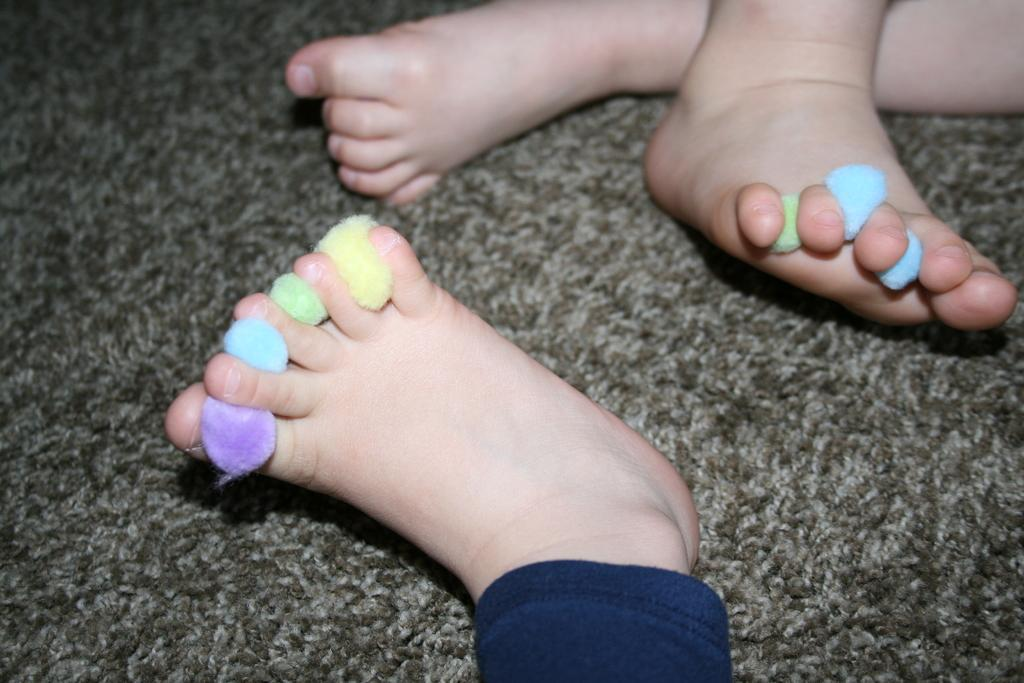What can be seen in the image related to children? There are legs of kids in the image. What is placed between the fingers of the kids' legs? There are objects placed between the fingers of the kids' legs. What type of meat is being prepared on the drum in the image? There is no meat or drum present in the image. The image only shows legs of kids with objects placed between their fingers. 